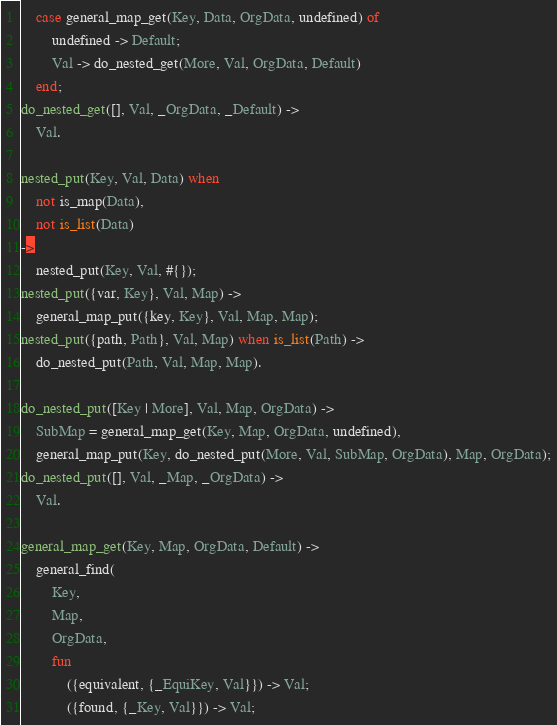Convert code to text. <code><loc_0><loc_0><loc_500><loc_500><_Erlang_>    case general_map_get(Key, Data, OrgData, undefined) of
        undefined -> Default;
        Val -> do_nested_get(More, Val, OrgData, Default)
    end;
do_nested_get([], Val, _OrgData, _Default) ->
    Val.

nested_put(Key, Val, Data) when
    not is_map(Data),
    not is_list(Data)
->
    nested_put(Key, Val, #{});
nested_put({var, Key}, Val, Map) ->
    general_map_put({key, Key}, Val, Map, Map);
nested_put({path, Path}, Val, Map) when is_list(Path) ->
    do_nested_put(Path, Val, Map, Map).

do_nested_put([Key | More], Val, Map, OrgData) ->
    SubMap = general_map_get(Key, Map, OrgData, undefined),
    general_map_put(Key, do_nested_put(More, Val, SubMap, OrgData), Map, OrgData);
do_nested_put([], Val, _Map, _OrgData) ->
    Val.

general_map_get(Key, Map, OrgData, Default) ->
    general_find(
        Key,
        Map,
        OrgData,
        fun
            ({equivalent, {_EquiKey, Val}}) -> Val;
            ({found, {_Key, Val}}) -> Val;</code> 